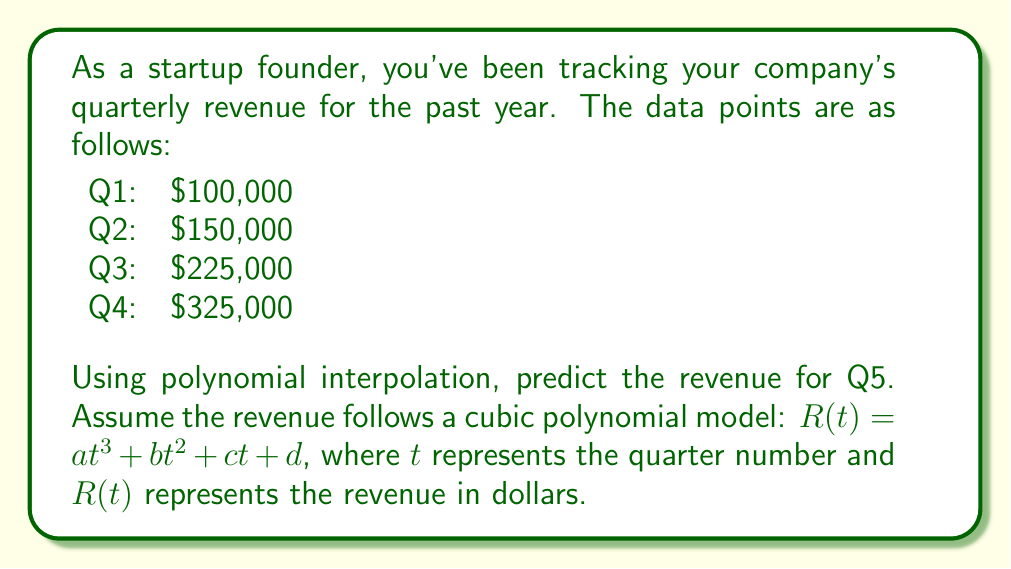Solve this math problem. To solve this problem, we'll use Lagrange interpolation to find the cubic polynomial that fits the given data points. Then, we'll use this polynomial to predict the revenue for Q5.

1. Set up the Lagrange interpolation formula:

$$R(t) = \sum_{i=1}^{4} y_i \cdot L_i(t)$$

Where $L_i(t)$ are the Lagrange basis polynomials:

$$L_i(t) = \prod_{j \neq i} \frac{t - t_j}{t_i - t_j}$$

2. Calculate the Lagrange basis polynomials:

$$L_1(t) = \frac{(t-2)(t-3)(t-4)}{(1-2)(1-3)(1-4)} = -\frac{1}{6}t^3 + t^2 - \frac{11}{6}t + 1$$
$$L_2(t) = \frac{(t-1)(t-3)(t-4)}{(2-1)(2-3)(2-4)} = \frac{1}{2}t^3 - 3t^2 + \frac{11}{2}t - 3$$
$$L_3(t) = \frac{(t-1)(t-2)(t-4)}{(3-1)(3-2)(3-4)} = -\frac{1}{2}t^3 + 3t^2 - \frac{13}{2}t + 3$$
$$L_4(t) = \frac{(t-1)(t-2)(t-3)}{(4-1)(4-2)(4-3)} = \frac{1}{6}t^3 - t^2 + \frac{11}{6}t - 1$$

3. Substitute the revenue values and simplify:

$$R(t) = 100000 \cdot L_1(t) + 150000 \cdot L_2(t) + 225000 \cdot L_3(t) + 325000 \cdot L_4(t)$$

$$R(t) = \frac{25000}{3}t^3 - 75000t^2 + \frac{695000}{6}t - 25000$$

4. To predict the revenue for Q5, evaluate $R(5)$:

$$R(5) = \frac{25000}{3}(125) - 75000(25) + \frac{695000}{6}(5) - 25000$$
$$R(5) = 1041666.67 - 1875000 + 579166.67 - 25000$$
$$R(5) = 450833.34$$

Therefore, the predicted revenue for Q5 is approximately $450,833.34.
Answer: $450,833.34 